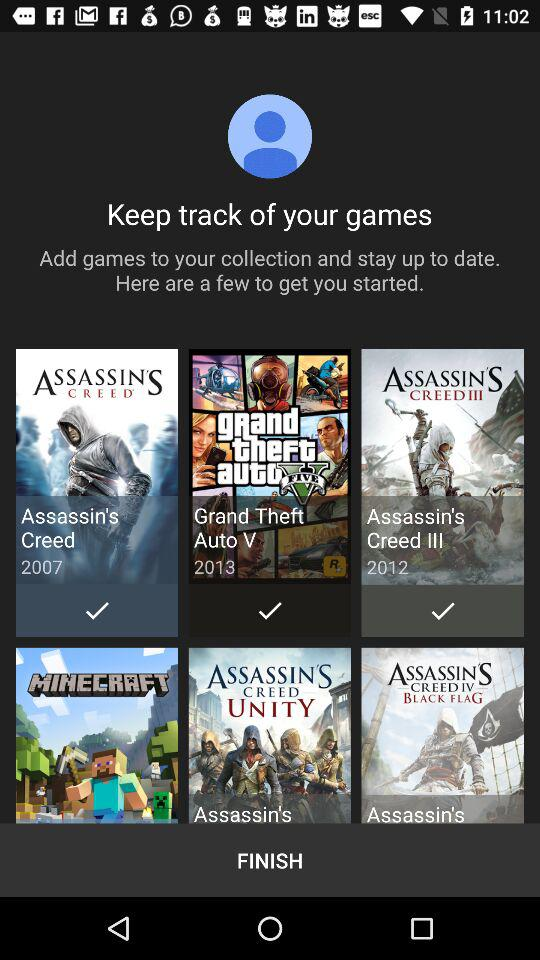What is the release year of "Assassin's Creed"? The release year is 2007. 